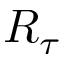Convert formula to latex. <formula><loc_0><loc_0><loc_500><loc_500>R _ { \tau }</formula> 